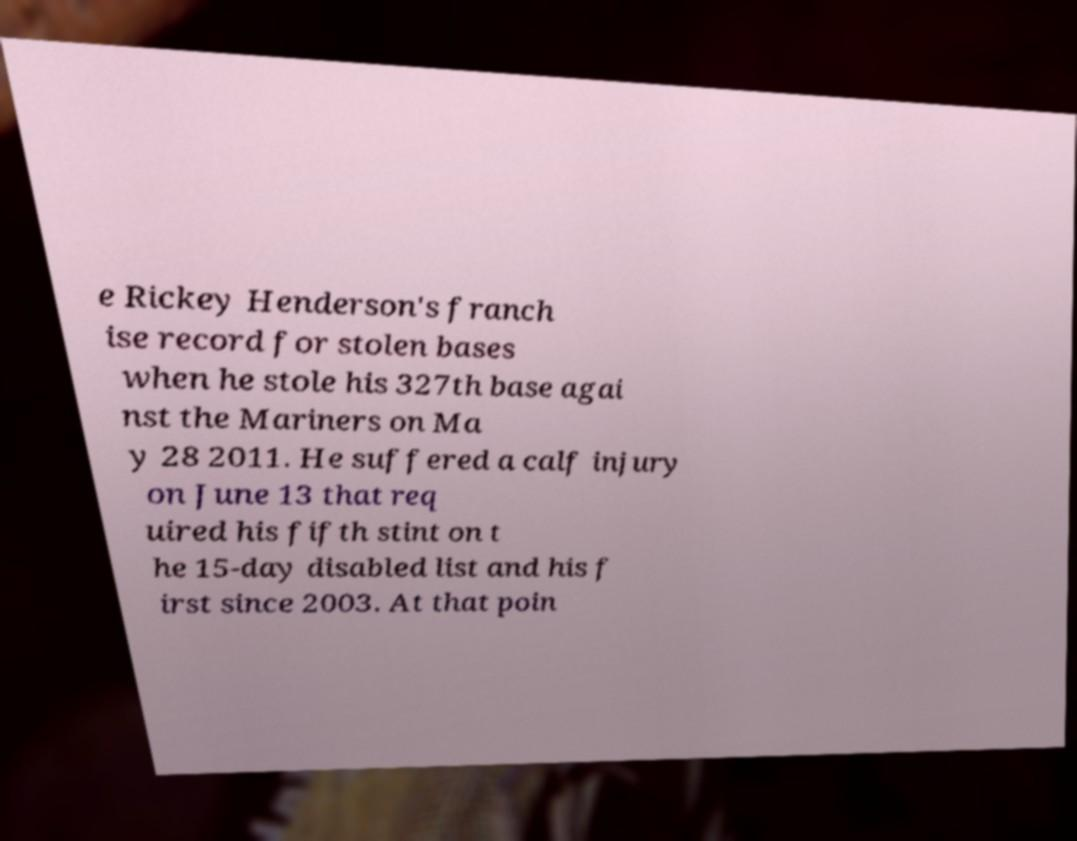Can you read and provide the text displayed in the image?This photo seems to have some interesting text. Can you extract and type it out for me? e Rickey Henderson's franch ise record for stolen bases when he stole his 327th base agai nst the Mariners on Ma y 28 2011. He suffered a calf injury on June 13 that req uired his fifth stint on t he 15-day disabled list and his f irst since 2003. At that poin 